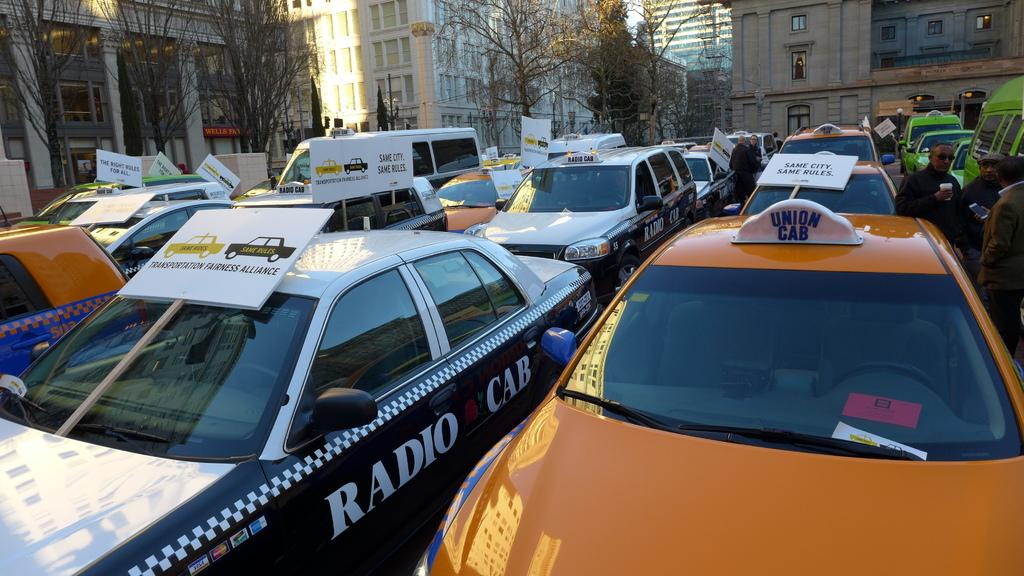<image>
Offer a succinct explanation of the picture presented. A Union cab and a Radio Cab side by side in traffic. 